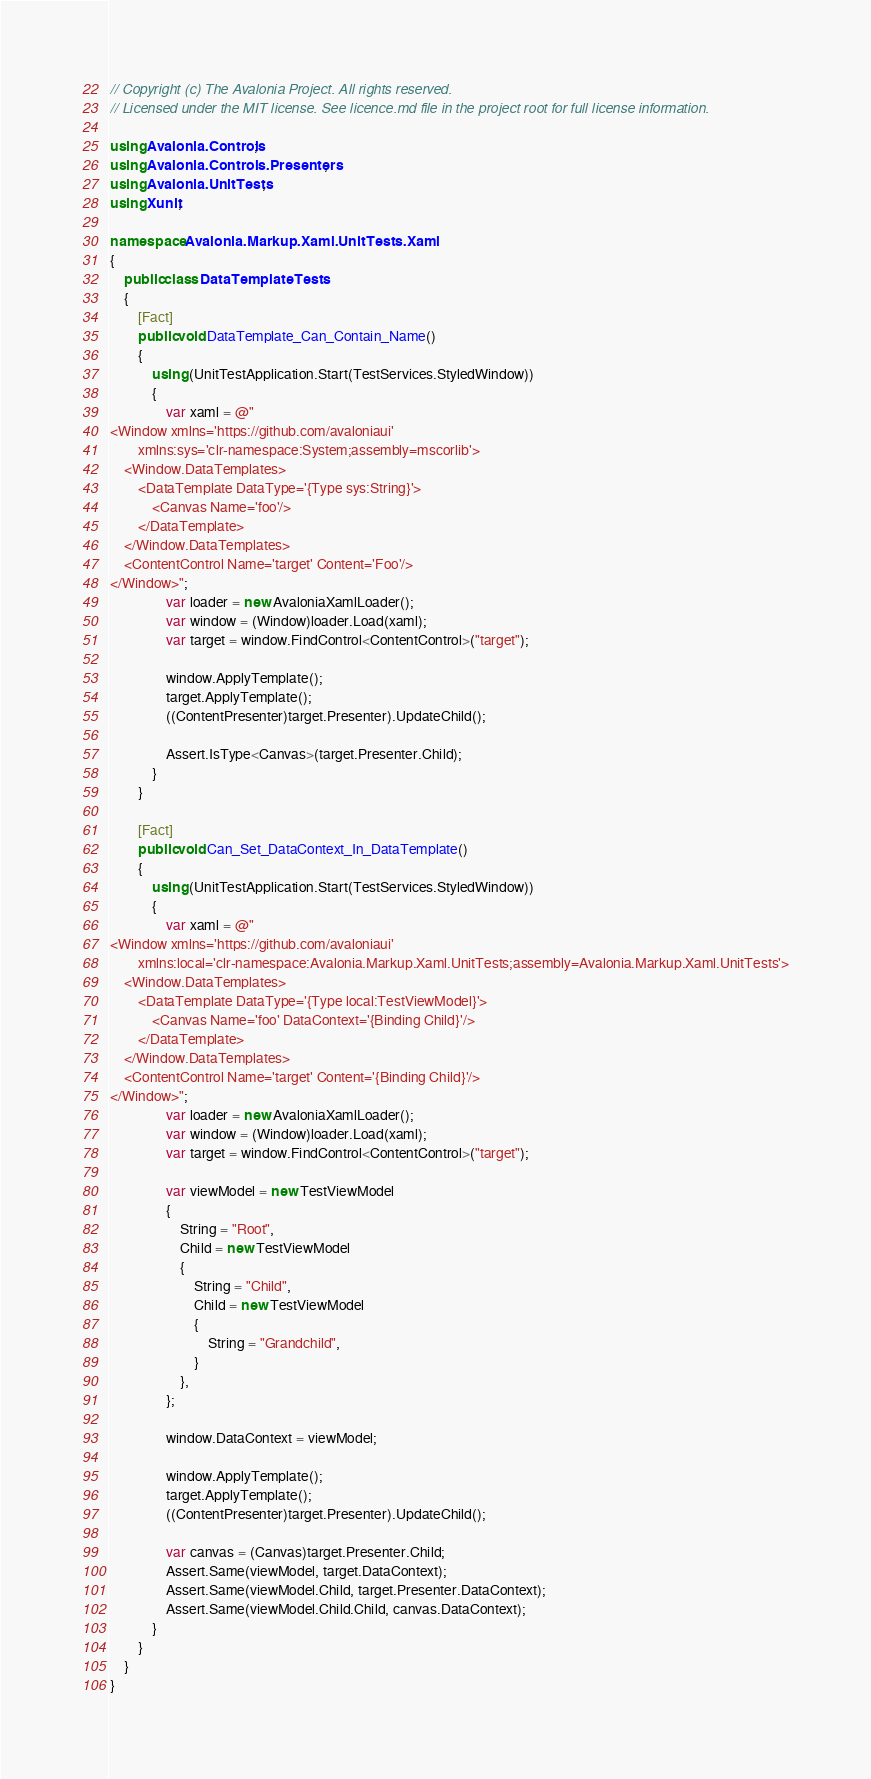Convert code to text. <code><loc_0><loc_0><loc_500><loc_500><_C#_>// Copyright (c) The Avalonia Project. All rights reserved.
// Licensed under the MIT license. See licence.md file in the project root for full license information.

using Avalonia.Controls;
using Avalonia.Controls.Presenters;
using Avalonia.UnitTests;
using Xunit;

namespace Avalonia.Markup.Xaml.UnitTests.Xaml
{
    public class DataTemplateTests
    {
        [Fact]
        public void DataTemplate_Can_Contain_Name()
        {
            using (UnitTestApplication.Start(TestServices.StyledWindow))
            {
                var xaml = @"
<Window xmlns='https://github.com/avaloniaui'
        xmlns:sys='clr-namespace:System;assembly=mscorlib'>
    <Window.DataTemplates>
        <DataTemplate DataType='{Type sys:String}'>
            <Canvas Name='foo'/>
        </DataTemplate>
    </Window.DataTemplates>
    <ContentControl Name='target' Content='Foo'/>
</Window>";
                var loader = new AvaloniaXamlLoader();
                var window = (Window)loader.Load(xaml);
                var target = window.FindControl<ContentControl>("target");

                window.ApplyTemplate();
                target.ApplyTemplate();
                ((ContentPresenter)target.Presenter).UpdateChild();

                Assert.IsType<Canvas>(target.Presenter.Child);
            }
        }

        [Fact]
        public void Can_Set_DataContext_In_DataTemplate()
        {
            using (UnitTestApplication.Start(TestServices.StyledWindow))
            {
                var xaml = @"
<Window xmlns='https://github.com/avaloniaui'
        xmlns:local='clr-namespace:Avalonia.Markup.Xaml.UnitTests;assembly=Avalonia.Markup.Xaml.UnitTests'>
    <Window.DataTemplates>
        <DataTemplate DataType='{Type local:TestViewModel}'>
            <Canvas Name='foo' DataContext='{Binding Child}'/>
        </DataTemplate>
    </Window.DataTemplates>
    <ContentControl Name='target' Content='{Binding Child}'/>
</Window>";
                var loader = new AvaloniaXamlLoader();
                var window = (Window)loader.Load(xaml);
                var target = window.FindControl<ContentControl>("target");

                var viewModel = new TestViewModel
                {
                    String = "Root",
                    Child = new TestViewModel
                    {
                        String = "Child",
                        Child = new TestViewModel
                        {
                            String = "Grandchild",
                        }
                    },
                };

                window.DataContext = viewModel;

                window.ApplyTemplate();
                target.ApplyTemplate();
                ((ContentPresenter)target.Presenter).UpdateChild();

                var canvas = (Canvas)target.Presenter.Child;
                Assert.Same(viewModel, target.DataContext);
                Assert.Same(viewModel.Child, target.Presenter.DataContext);
                Assert.Same(viewModel.Child.Child, canvas.DataContext);
            }
        }
    }
}
</code> 